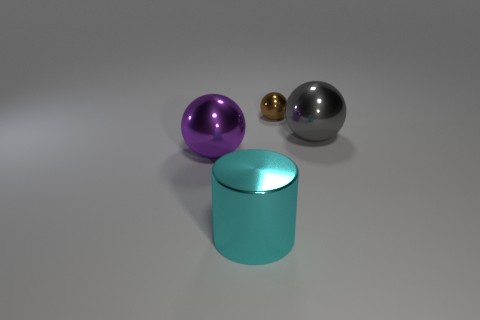Add 3 large gray things. How many objects exist? 7 Add 1 large purple metal objects. How many large purple metal objects exist? 2 Subtract all gray spheres. How many spheres are left? 2 Subtract all small metal balls. How many balls are left? 2 Subtract 1 brown spheres. How many objects are left? 3 Subtract all cylinders. How many objects are left? 3 Subtract 1 cylinders. How many cylinders are left? 0 Subtract all red spheres. Subtract all purple cylinders. How many spheres are left? 3 Subtract all red blocks. How many purple spheres are left? 1 Subtract all gray spheres. Subtract all large gray shiny balls. How many objects are left? 2 